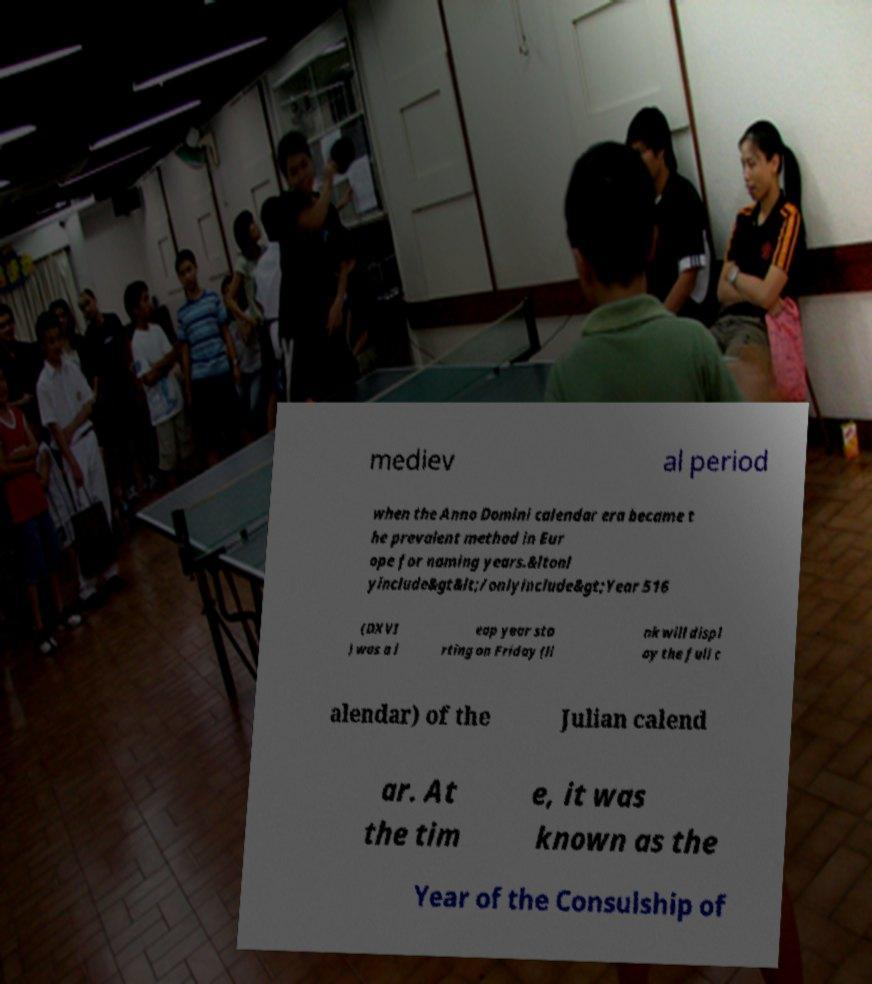For documentation purposes, I need the text within this image transcribed. Could you provide that? mediev al period when the Anno Domini calendar era became t he prevalent method in Eur ope for naming years.&ltonl yinclude&gt&lt;/onlyinclude&gt;Year 516 (DXVI ) was a l eap year sta rting on Friday (li nk will displ ay the full c alendar) of the Julian calend ar. At the tim e, it was known as the Year of the Consulship of 